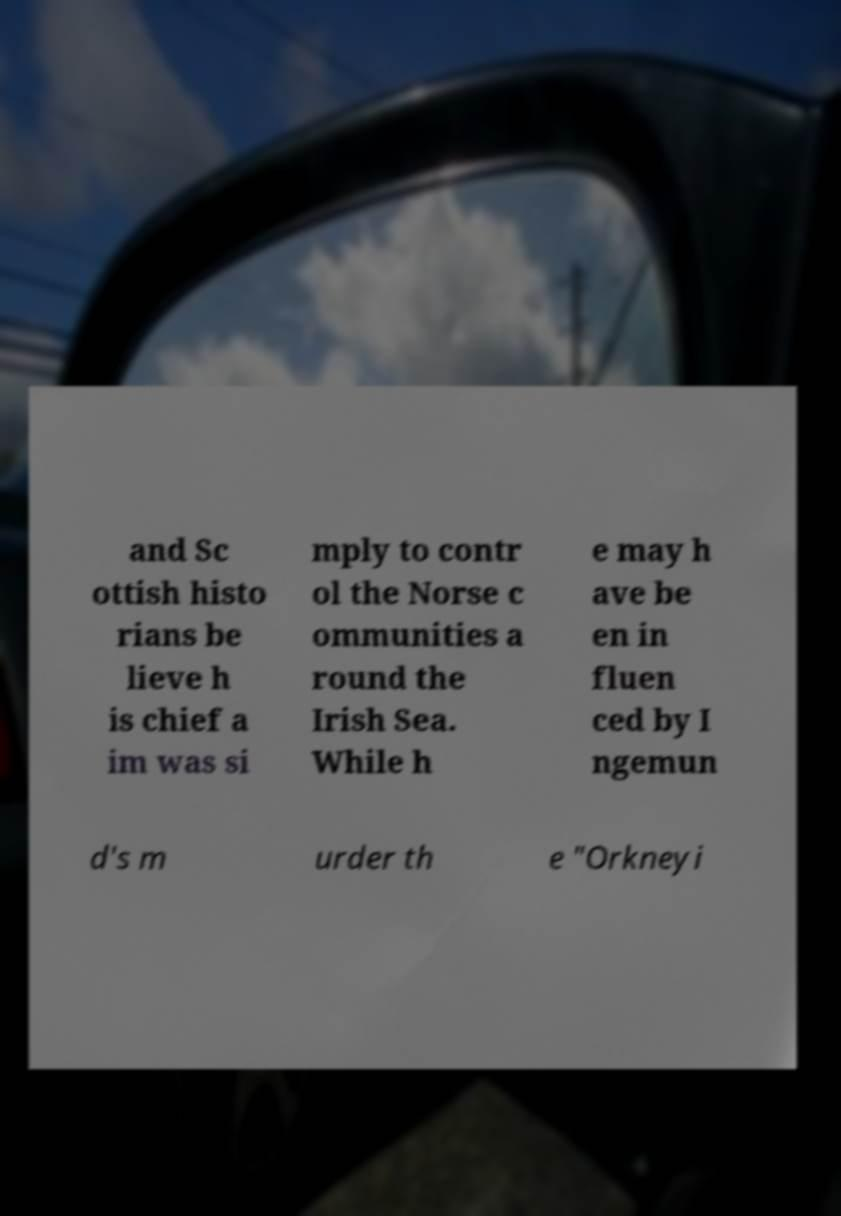Can you accurately transcribe the text from the provided image for me? and Sc ottish histo rians be lieve h is chief a im was si mply to contr ol the Norse c ommunities a round the Irish Sea. While h e may h ave be en in fluen ced by I ngemun d's m urder th e "Orkneyi 